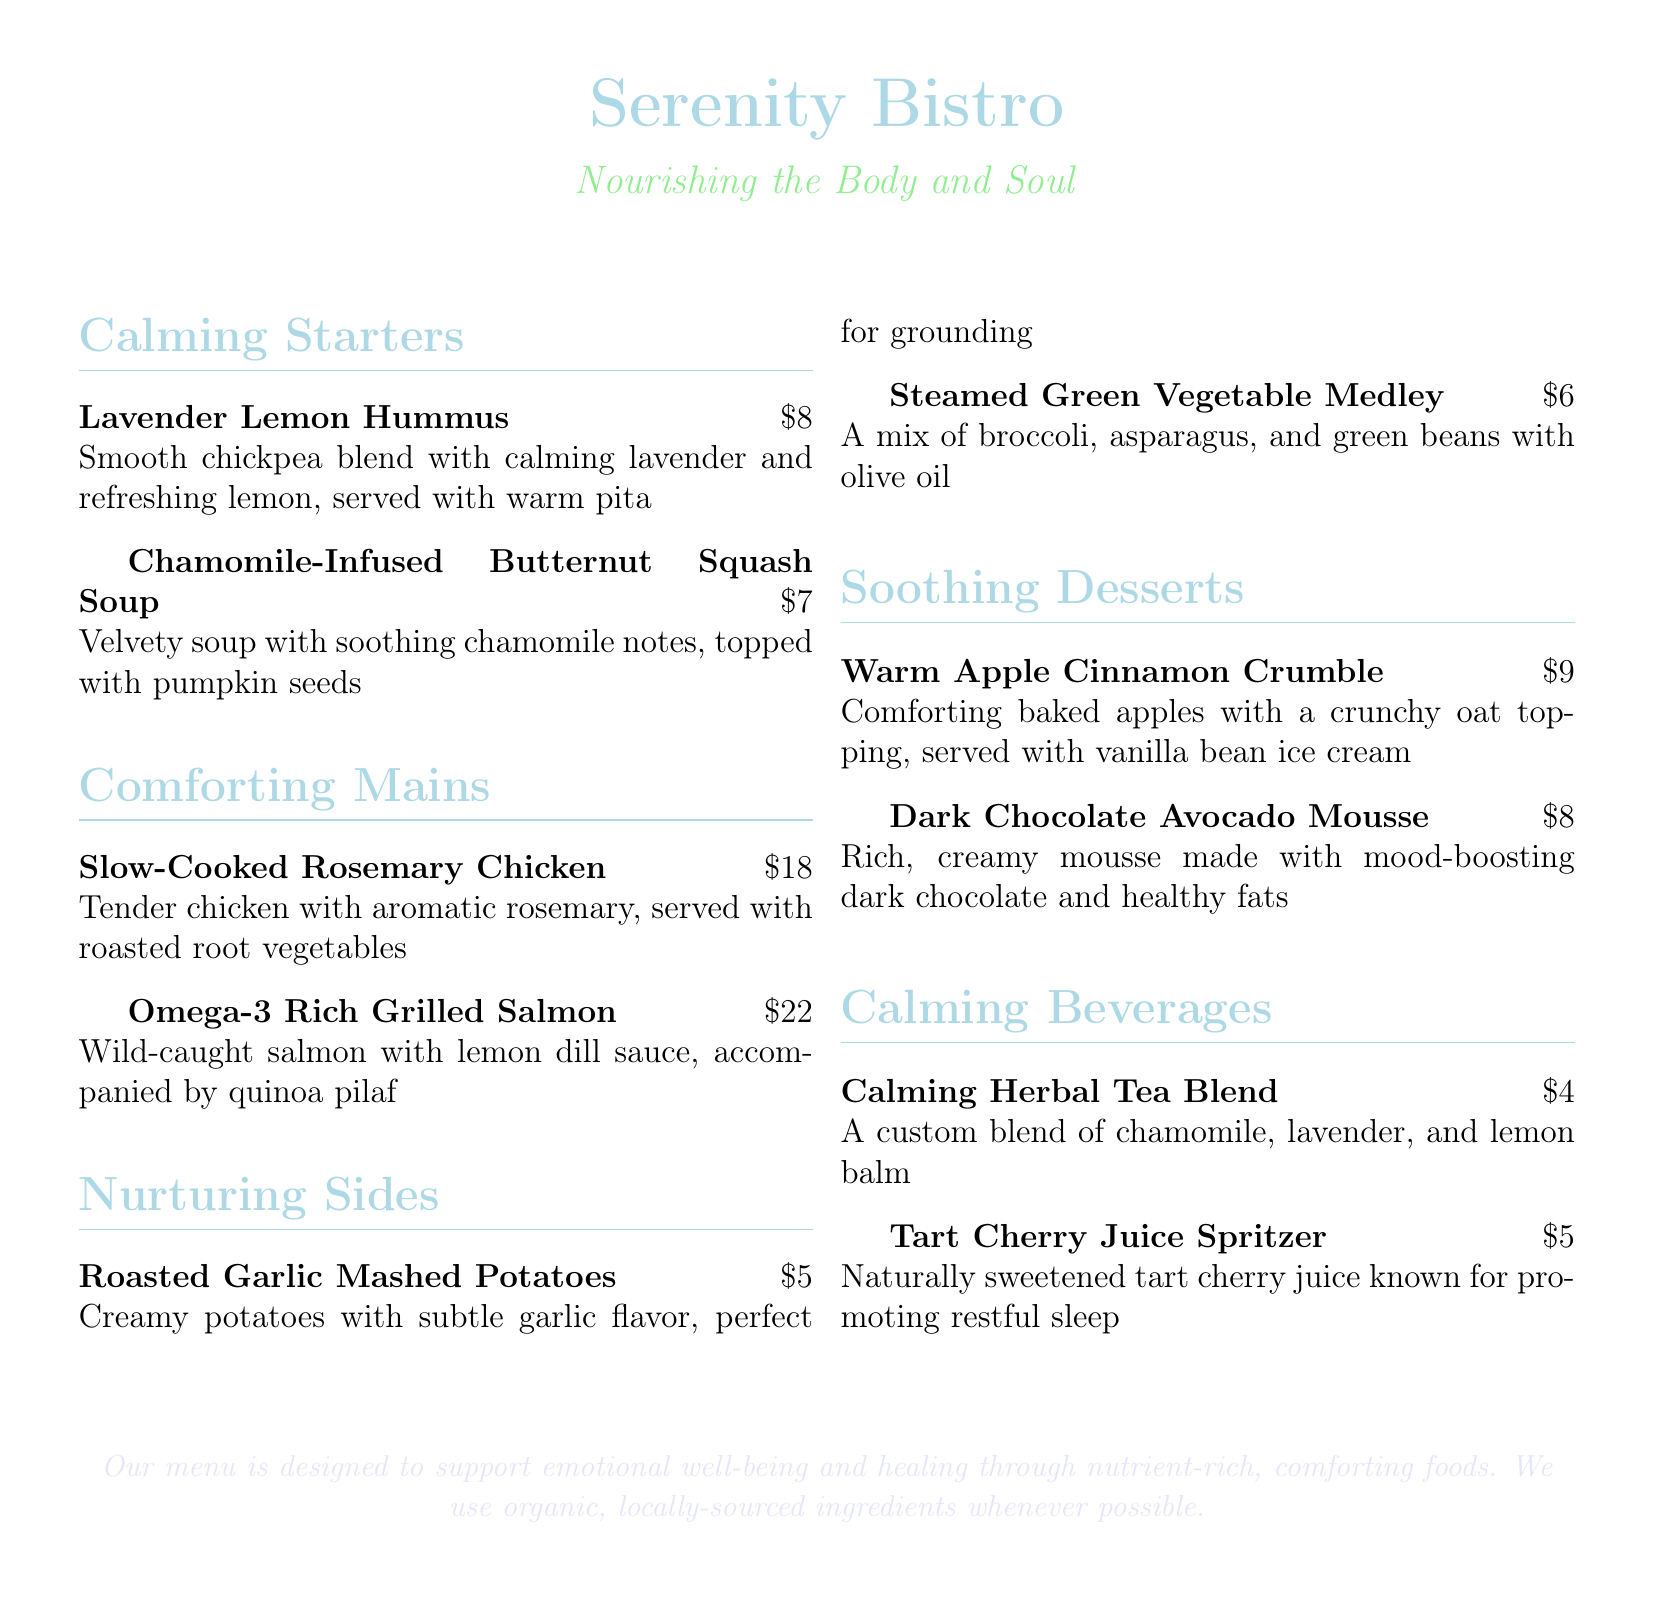What is the name of the restaurant? The name of the restaurant is prominently displayed at the top of the menu.
Answer: Serenity Bistro How much is the Chamomile-Infused Butternut Squash Soup? The price is listed next to the dish.
Answer: $7 Which dish includes salmon? The menu specifies the dish that features salmon in the Comforting Mains section.
Answer: Omega-3 Rich Grilled Salmon What are the ingredients in the Dark Chocolate Avocado Mousse? The dessert description includes the primary components of the dish.
Answer: Dark chocolate and avocado How many calming beverages are listed on the menu? The menu contains a specific section dedicated to beverages.
Answer: 2 What type of tea is offered? The beverage section provides the specific type of tea available at the restaurant.
Answer: Calming Herbal Tea Blend Which starter features lavender? The menu lists a starter that specifically mentions lavender in its description.
Answer: Lavender Lemon Hummus What is the purpose of the menu's design? The text at the bottom of the menu outlines the main intention behind its creation.
Answer: Support emotional well-being and healing 